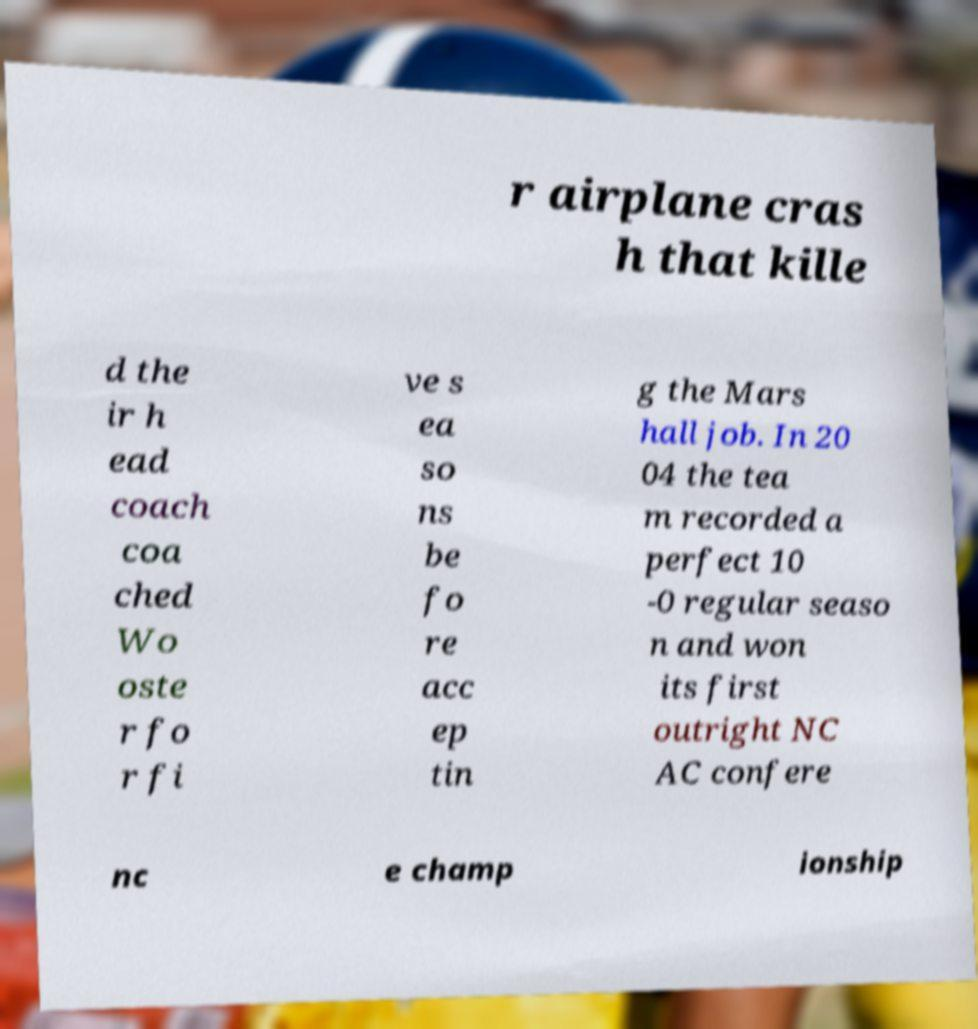I need the written content from this picture converted into text. Can you do that? r airplane cras h that kille d the ir h ead coach coa ched Wo oste r fo r fi ve s ea so ns be fo re acc ep tin g the Mars hall job. In 20 04 the tea m recorded a perfect 10 -0 regular seaso n and won its first outright NC AC confere nc e champ ionship 